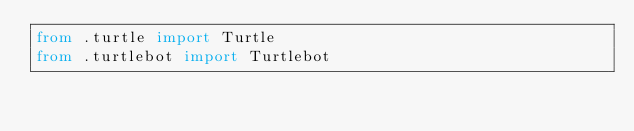Convert code to text. <code><loc_0><loc_0><loc_500><loc_500><_Python_>from .turtle import Turtle
from .turtlebot import Turtlebot
</code> 